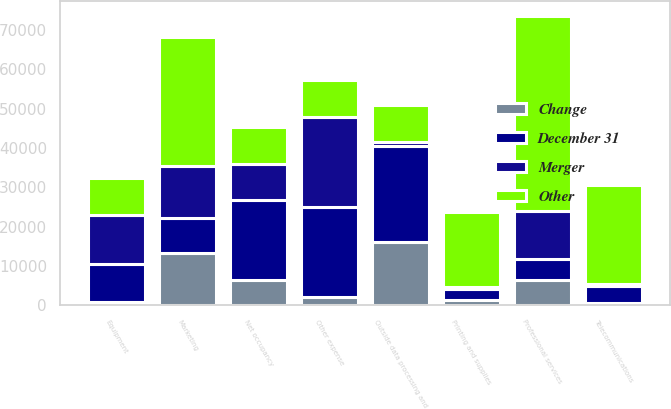Convert chart. <chart><loc_0><loc_0><loc_500><loc_500><stacked_bar_chart><ecel><fcel>Outside data processing and<fcel>Net occupancy<fcel>Equipment<fcel>Professional services<fcel>Marketing<fcel>Telecommunications<fcel>Printing and supplies<fcel>Other expense<nl><fcel>Other<fcel>9326.5<fcel>9326.5<fcel>9326.5<fcel>49613<fcel>32664<fcel>25008<fcel>18870<fcel>9326.5<nl><fcel>Merger<fcel>1000<fcel>9055<fcel>12483<fcel>12223<fcel>13379<fcel>506<fcel>619<fcel>22997<nl><fcel>December 31<fcel>24524<fcel>20368<fcel>9598<fcel>5414<fcel>8722<fcel>4448<fcel>2748<fcel>22696<nl><fcel>Change<fcel>16017<fcel>6487<fcel>942<fcel>6399<fcel>13410<fcel>550<fcel>1433<fcel>2267<nl></chart> 